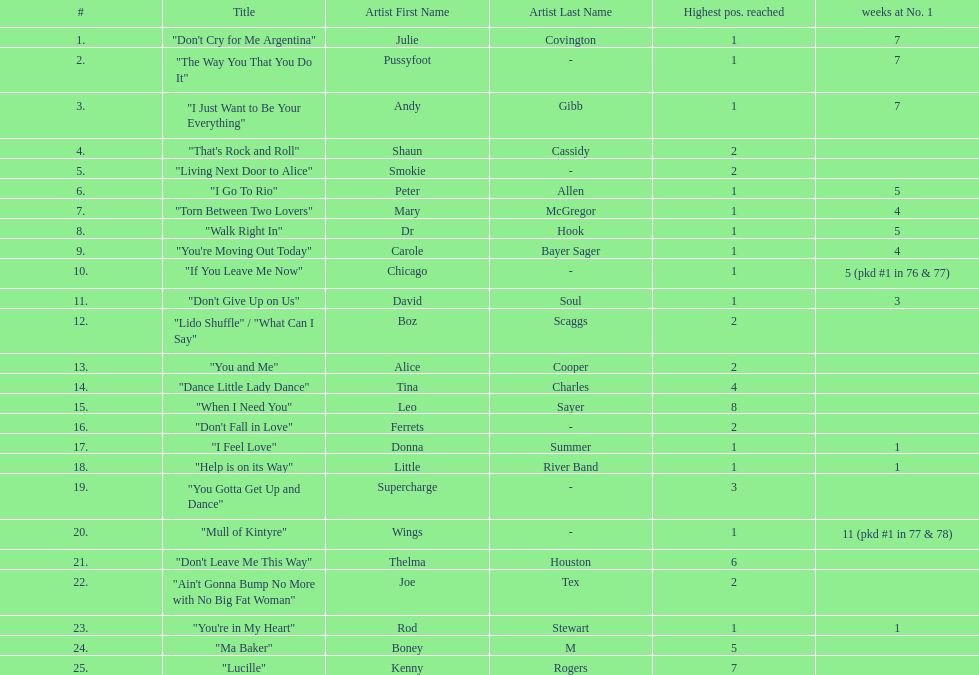Could you help me parse every detail presented in this table? {'header': ['#', 'Title', 'Artist First Name', 'Artist Last Name', 'Highest pos. reached', 'weeks at No. 1'], 'rows': [['1.', '"Don\'t Cry for Me Argentina"', 'Julie', 'Covington', '1', '7'], ['2.', '"The Way You That You Do It"', 'Pussyfoot', '-', '1', '7'], ['3.', '"I Just Want to Be Your Everything"', 'Andy', 'Gibb', '1', '7'], ['4.', '"That\'s Rock and Roll"', 'Shaun', 'Cassidy', '2', ''], ['5.', '"Living Next Door to Alice"', 'Smokie', '-', '2', ''], ['6.', '"I Go To Rio"', 'Peter', 'Allen', '1', '5'], ['7.', '"Torn Between Two Lovers"', 'Mary', 'McGregor', '1', '4'], ['8.', '"Walk Right In"', 'Dr', 'Hook', '1', '5'], ['9.', '"You\'re Moving Out Today"', 'Carole', 'Bayer Sager', '1', '4'], ['10.', '"If You Leave Me Now"', 'Chicago', '-', '1', '5 (pkd #1 in 76 & 77)'], ['11.', '"Don\'t Give Up on Us"', 'David', 'Soul', '1', '3'], ['12.', '"Lido Shuffle" / "What Can I Say"', 'Boz', 'Scaggs', '2', ''], ['13.', '"You and Me"', 'Alice', 'Cooper', '2', ''], ['14.', '"Dance Little Lady Dance"', 'Tina', 'Charles', '4', ''], ['15.', '"When I Need You"', 'Leo', 'Sayer', '8', ''], ['16.', '"Don\'t Fall in Love"', 'Ferrets', '-', '2', ''], ['17.', '"I Feel Love"', 'Donna', 'Summer', '1', '1'], ['18.', '"Help is on its Way"', 'Little', 'River Band', '1', '1'], ['19.', '"You Gotta Get Up and Dance"', 'Supercharge', '-', '3', ''], ['20.', '"Mull of Kintyre"', 'Wings', '-', '1', '11 (pkd #1 in 77 & 78)'], ['21.', '"Don\'t Leave Me This Way"', 'Thelma', 'Houston', '6', ''], ['22.', '"Ain\'t Gonna Bump No More with No Big Fat Woman"', 'Joe', 'Tex', '2', ''], ['23.', '"You\'re in My Heart"', 'Rod', 'Stewart', '1', '1'], ['24.', '"Ma Baker"', 'Boney', 'M', '5', ''], ['25.', '"Lucille"', 'Kenny', 'Rogers', '7', '']]} Which song stayed at no.1 for the most amount of weeks. "Mull of Kintyre". 